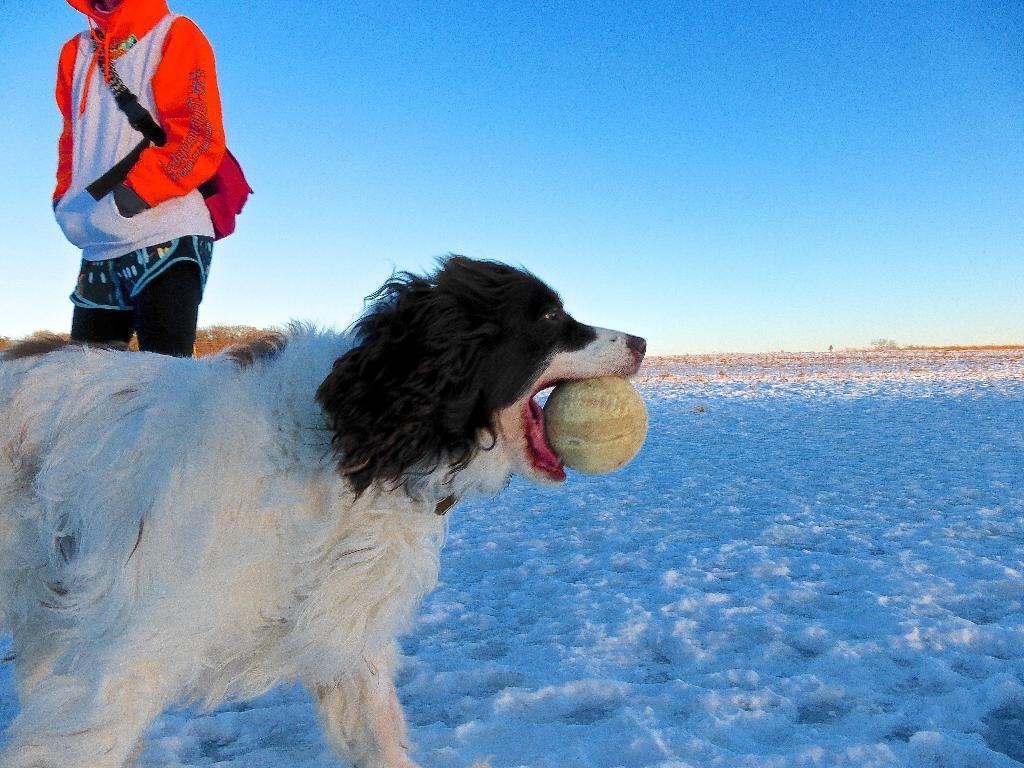In one or two sentences, can you explain what this image depicts? In this picture I can see a dog in front, which is of white and black color and I see that the dog is holding a ball in the mouth and I see the white snow. On the left side of this image I see a person who is standing. In the background I can see the clear sky. 